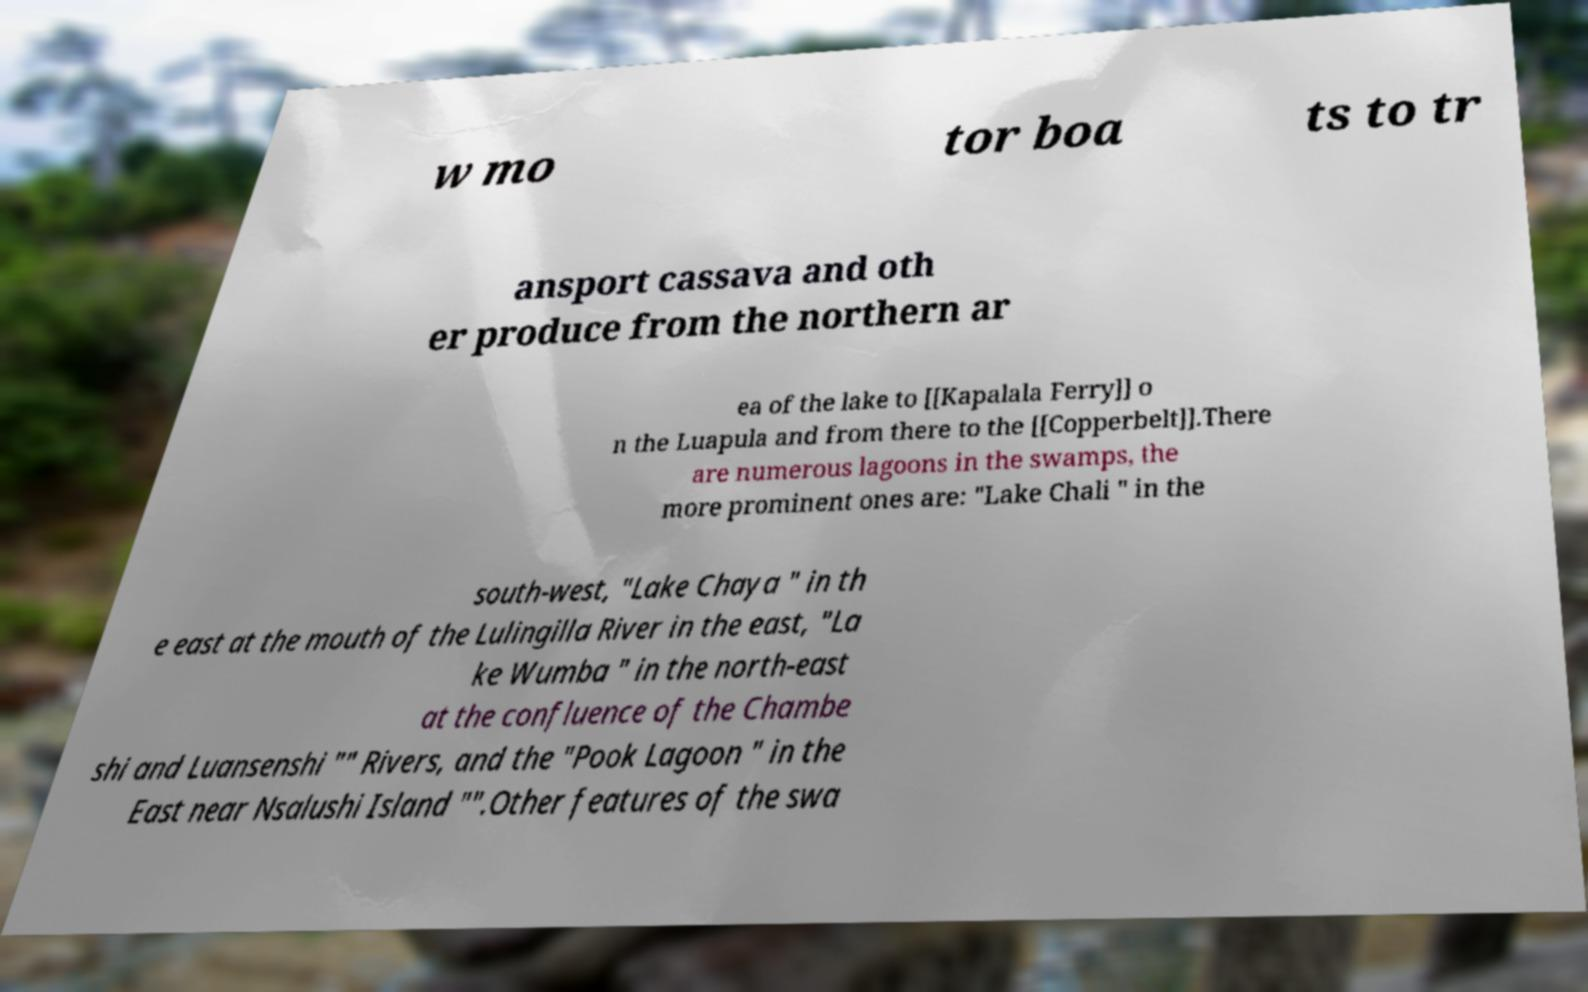Please identify and transcribe the text found in this image. w mo tor boa ts to tr ansport cassava and oth er produce from the northern ar ea of the lake to [[Kapalala Ferry]] o n the Luapula and from there to the [[Copperbelt]].There are numerous lagoons in the swamps, the more prominent ones are: "Lake Chali " in the south-west, "Lake Chaya " in th e east at the mouth of the Lulingilla River in the east, "La ke Wumba " in the north-east at the confluence of the Chambe shi and Luansenshi "" Rivers, and the "Pook Lagoon " in the East near Nsalushi Island "".Other features of the swa 